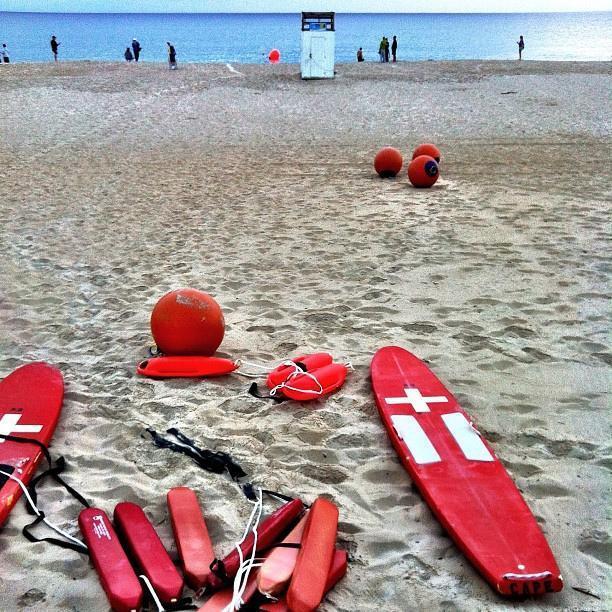How many surfboards can be seen?
Give a very brief answer. 2. 